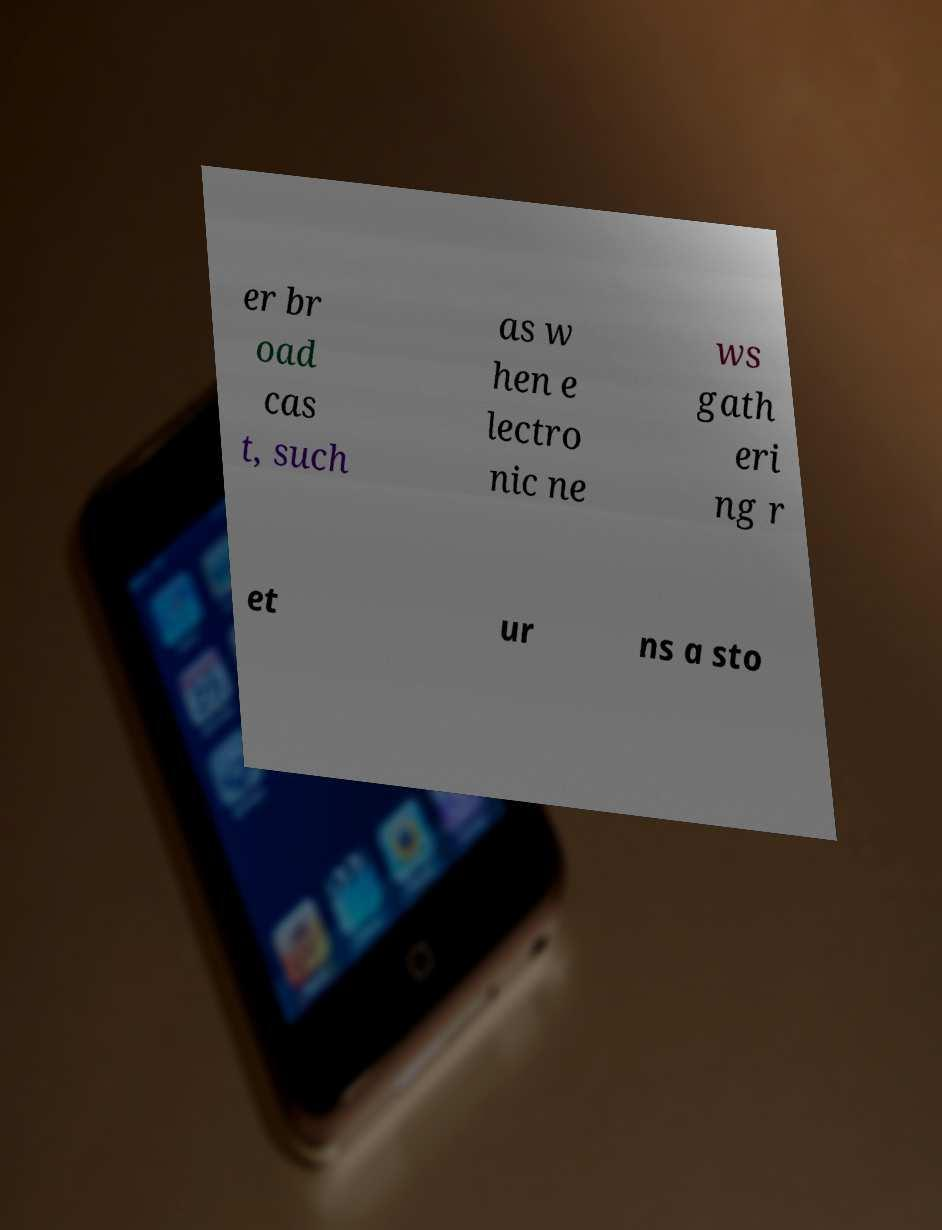Can you accurately transcribe the text from the provided image for me? er br oad cas t, such as w hen e lectro nic ne ws gath eri ng r et ur ns a sto 